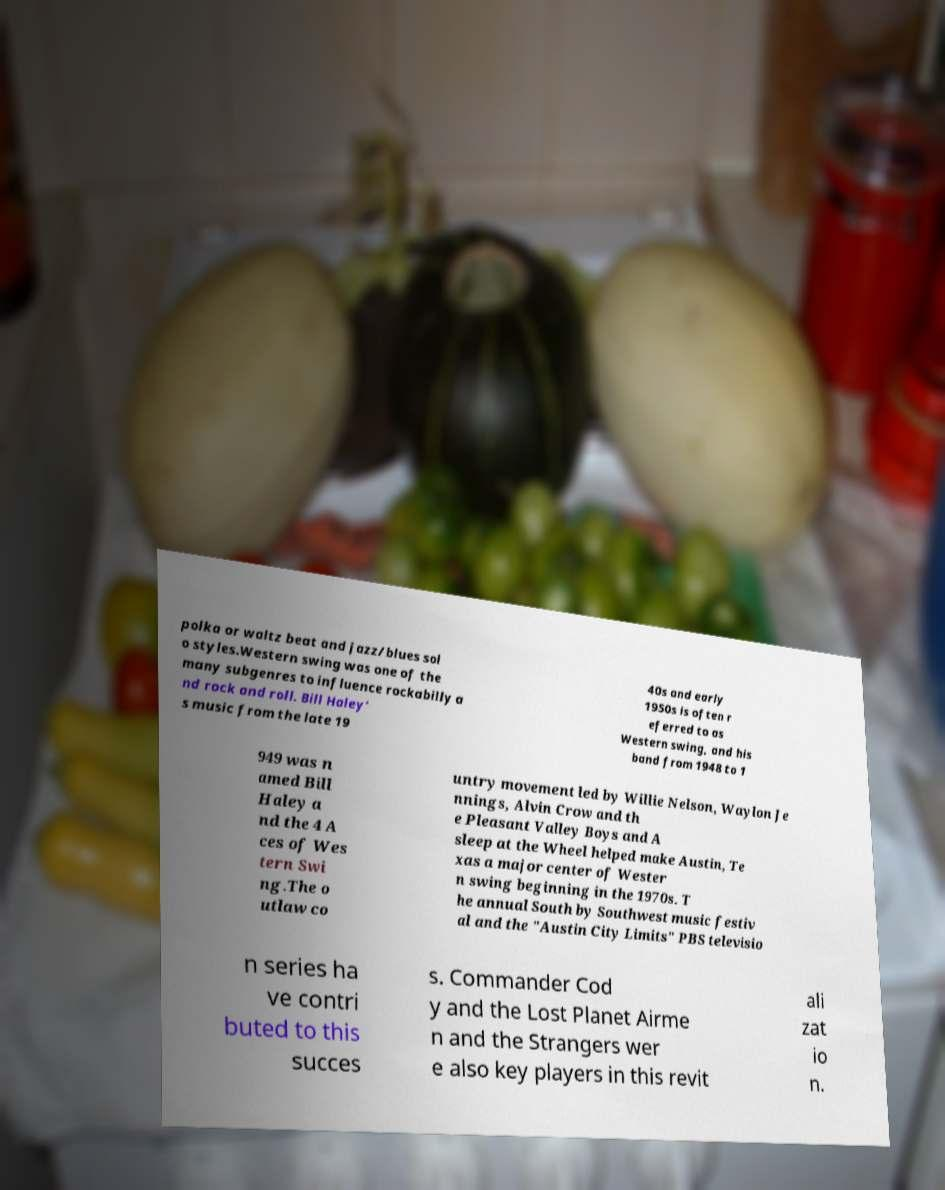For documentation purposes, I need the text within this image transcribed. Could you provide that? polka or waltz beat and jazz/blues sol o styles.Western swing was one of the many subgenres to influence rockabilly a nd rock and roll. Bill Haley' s music from the late 19 40s and early 1950s is often r eferred to as Western swing, and his band from 1948 to 1 949 was n amed Bill Haley a nd the 4 A ces of Wes tern Swi ng.The o utlaw co untry movement led by Willie Nelson, Waylon Je nnings, Alvin Crow and th e Pleasant Valley Boys and A sleep at the Wheel helped make Austin, Te xas a major center of Wester n swing beginning in the 1970s. T he annual South by Southwest music festiv al and the "Austin City Limits" PBS televisio n series ha ve contri buted to this succes s. Commander Cod y and the Lost Planet Airme n and the Strangers wer e also key players in this revit ali zat io n. 